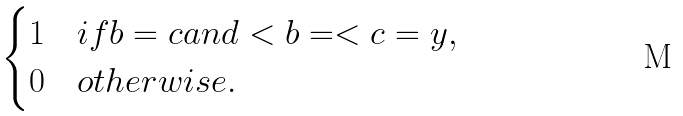<formula> <loc_0><loc_0><loc_500><loc_500>\begin{cases} 1 & i f b = c a n d < { b } = < { c } = y , \\ 0 & o t h e r w i s e . \end{cases}</formula> 